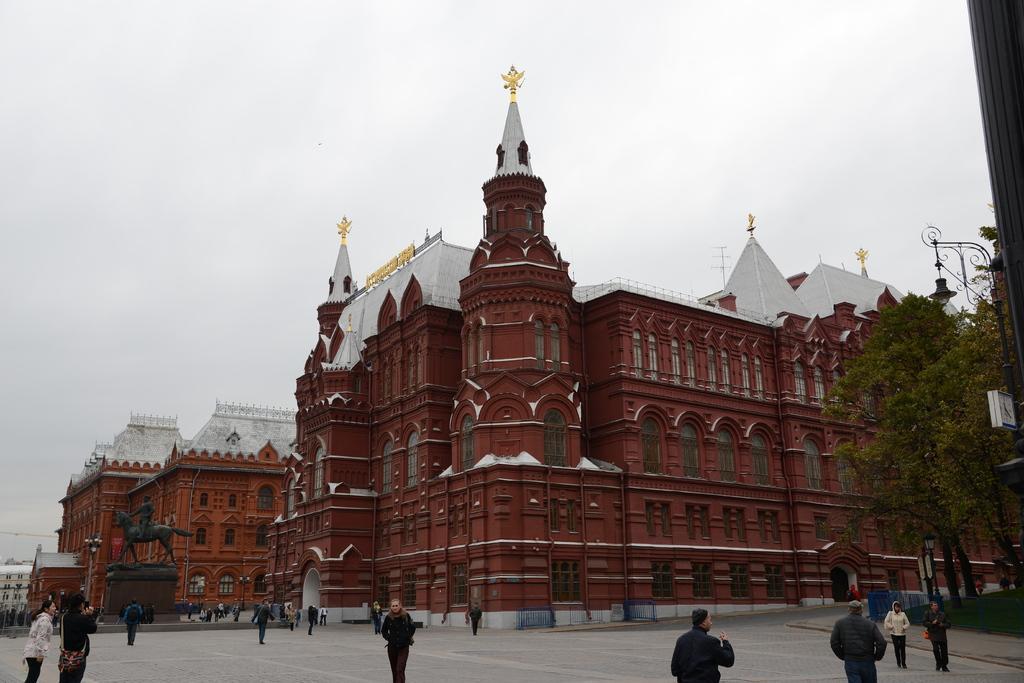How would you summarize this image in a sentence or two? In this image in the center there are some buildings, and also there are some persons who are walking and some of them are standing. And also there are some trees, poles, lights. And on the left side there is one statue, at the bottom there is a walkway and in the background there is sky. 